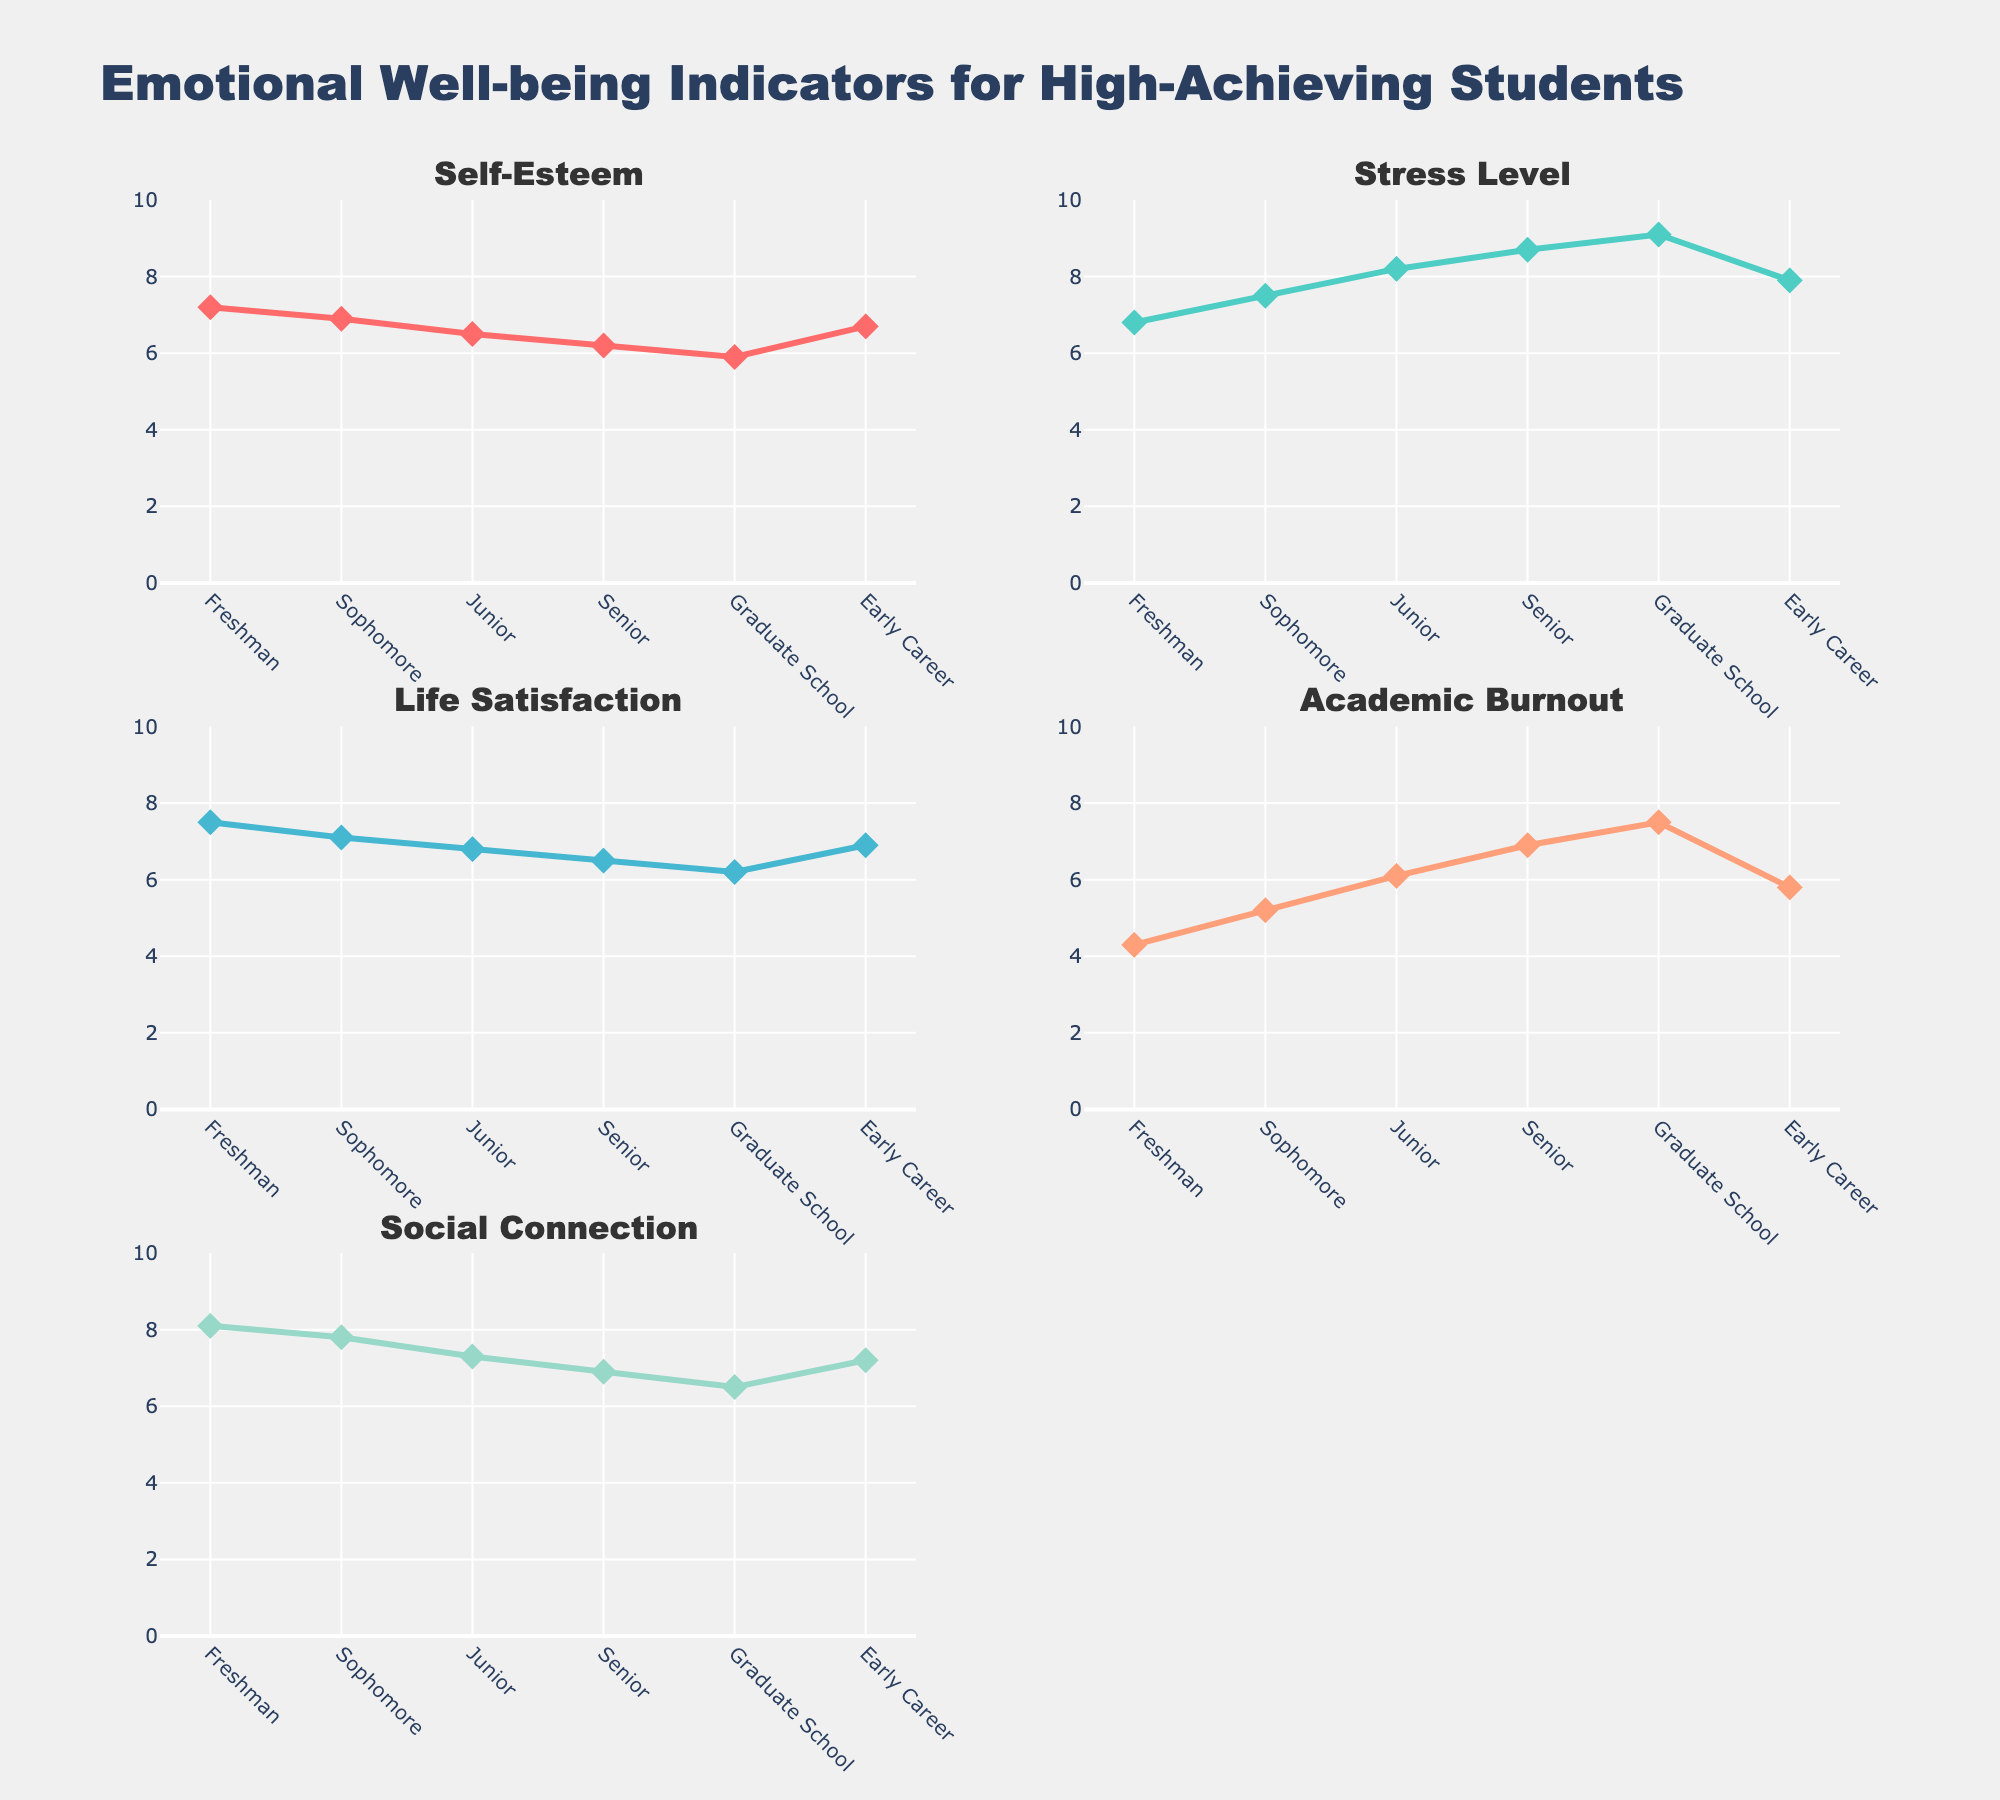What is the color of the plot for Academic Burnout? The color of each indicator is specified in the legend within the figure. Academic Burnout is represented by the fourth color option, which is a shade of orange.
Answer: Orange (light salmon) What is the overall trend for Self-Esteem throughout the academic journey? Examine the Self-Esteem subplot from Freshman to Early Career. Notice that the Self-Esteem values are generally decreasing over time, with a slight increase noticed at the Early Career point.
Answer: Decreasing trend What is the difference in Stress Level between the Sophomore and Senior years? From the Stress Level subplot, observe the values for the Sophomore year (7.5) and Senior year (8.7). The difference is calculated as 8.7 - 7.5.
Answer: 1.2 How does Social Connection change from Freshman to Graduate School? Look at the Social Connection subplot from Freshman year (8.1) to Graduate School (6.5). Note that there is a decrease indicated in these years.
Answer: Decreases Which year shows the highest level of Life Satisfaction? In the Life Satisfaction subplot, you can see the highest point on the graph. The Freshman year has the highest value at 7.5.
Answer: Freshman Compare the trend of Academic Burnout and Stress Level over the years. Which one increases more steeply? Observe the trends in both subplots. Both show an increasing trend, but Stress Level increases more steeply, going from 6.8 to 9.1 compared to Academic Burnout, which increases from 4.3 to 7.5.
Answer: Stress Level What is the average value of Self-Esteem over the entire academic journey? Average value is calculated by summing up all the values for Self-Esteem (7.2 + 6.9 + 6.5 + 6.2 + 5.9 + 6.7) and dividing by the number of years (6). The sum is 39.4, and the average is 39.4/6.
Answer: 6.57 